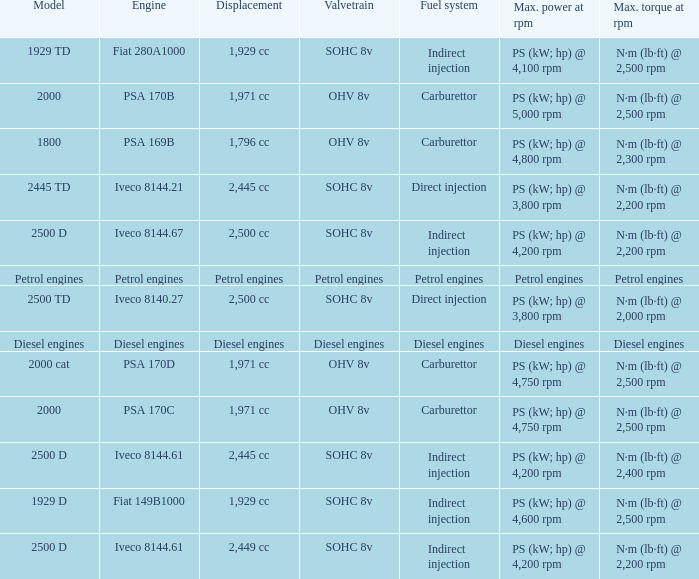What is the maximum torque that has 2,445 CC Displacement, and an Iveco 8144.61 engine? N·m (lb·ft) @ 2,400 rpm. 